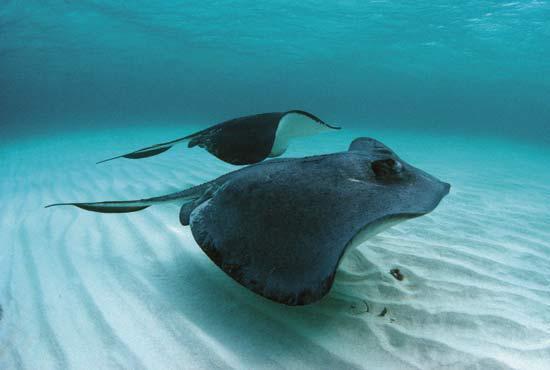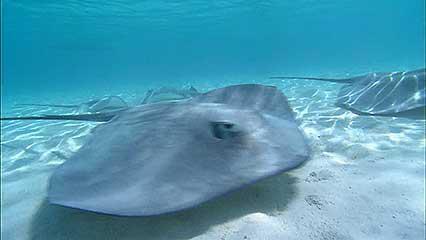The first image is the image on the left, the second image is the image on the right. Evaluate the accuracy of this statement regarding the images: "A person is touching a ray with their hand.". Is it true? Answer yes or no. No. The first image is the image on the left, the second image is the image on the right. For the images displayed, is the sentence "The image on the left contains a persons hand stroking a small string ray." factually correct? Answer yes or no. No. 